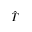<formula> <loc_0><loc_0><loc_500><loc_500>\hat { T }</formula> 